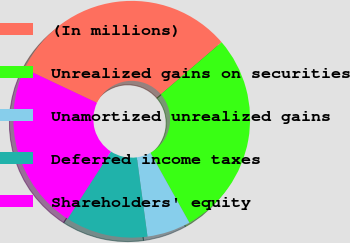Convert chart. <chart><loc_0><loc_0><loc_500><loc_500><pie_chart><fcel>(In millions)<fcel>Unrealized gains on securities<fcel>Unamortized unrealized gains<fcel>Deferred income taxes<fcel>Shareholders' equity<nl><fcel>31.7%<fcel>28.18%<fcel>5.97%<fcel>11.24%<fcel>22.91%<nl></chart> 